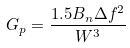<formula> <loc_0><loc_0><loc_500><loc_500>G _ { p } = \frac { 1 . 5 B _ { n } \Delta f ^ { 2 } } { W ^ { 3 } }</formula> 